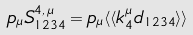<formula> <loc_0><loc_0><loc_500><loc_500>p _ { \mu } S _ { 1 2 3 4 } ^ { 4 , \, \mu } = p _ { \mu } \langle \langle k _ { 4 } ^ { \mu } d _ { 1 2 3 4 } \rangle \rangle</formula> 